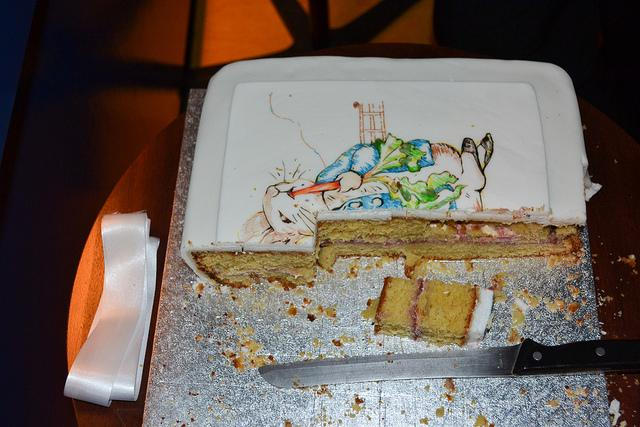Which age range may this cake have been for? child 